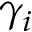Convert formula to latex. <formula><loc_0><loc_0><loc_500><loc_500>\gamma _ { i }</formula> 